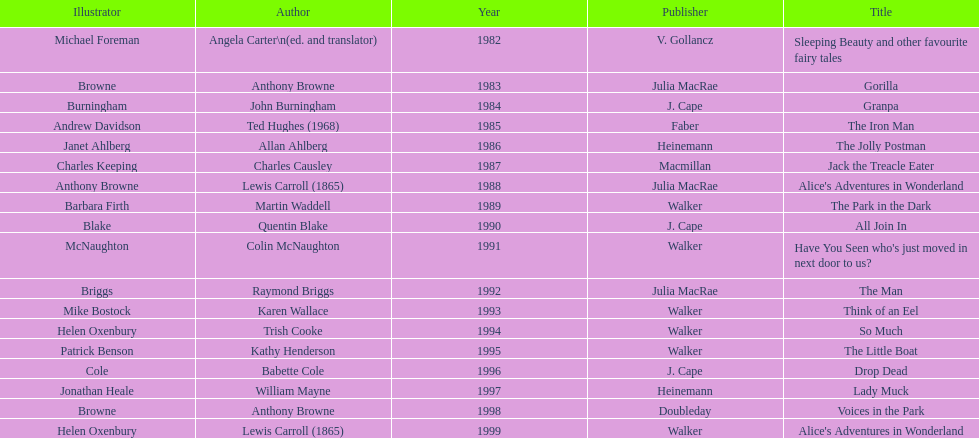What's the difference in years between angela carter's title and anthony browne's? 1. 